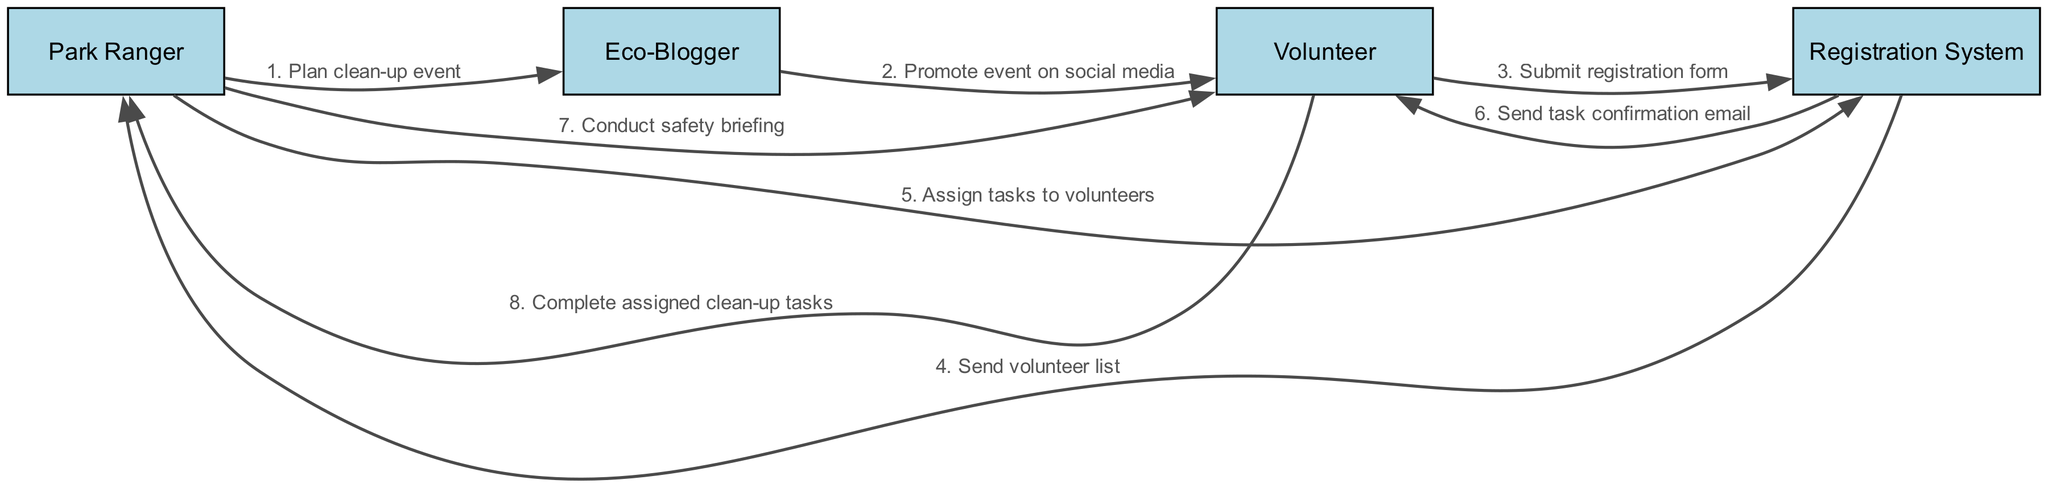What is the first action in the sequence? The first action is initiated by the Park Ranger who plans the clean-up event. This is the starting point, shown as the first message directed to the Eco-Blogger.
Answer: Plan clean-up event Who promotes the event on social media? The Eco-Blogger is responsible for promoting the event on social media, which is indicated as the second action in the sequence.
Answer: Eco-Blogger How many actors are involved in this process? The diagram indicates four distinct actors: Park Ranger, Eco-Blogger, Volunteer, and Registration System, leading to a count of four actors in total.
Answer: Four What message does the Volunteer send to the Registration System? The Volunteer submits the registration form as indicated by the third action in the sequence, which specifies this communication.
Answer: Submit registration form What is the role of the Registration System after receiving the registration form? After receiving the registration form from the Volunteer, the Registration System sends the volunteer list to the Park Ranger, as described by the fourth action. This clearly defines its role in the sequence.
Answer: Send volunteer list Which actor conducts a safety briefing? The Park Ranger is responsible for conducting the safety briefing, which is the sixth action in the sequence, indicating their involvement in educating the Volunteers.
Answer: Park Ranger In which step does the Volunteer receive a task confirmation email? The task confirmation email is sent to the Volunteer by the Registration System as part of the fifth action in the sequence, reflecting the confirmation of assigned tasks.
Answer: Send task confirmation email What task do Volunteers complete after the safety briefing? After the safety briefing conducted by the Park Ranger, the Volunteers complete their assigned clean-up tasks as indicated in the last action of the sequence.
Answer: Complete assigned clean-up tasks 